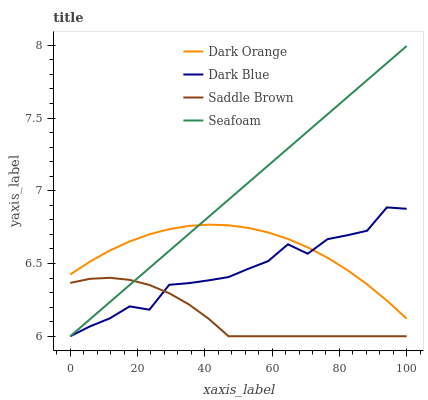Does Saddle Brown have the minimum area under the curve?
Answer yes or no. Yes. Does Seafoam have the maximum area under the curve?
Answer yes or no. Yes. Does Seafoam have the minimum area under the curve?
Answer yes or no. No. Does Saddle Brown have the maximum area under the curve?
Answer yes or no. No. Is Seafoam the smoothest?
Answer yes or no. Yes. Is Dark Blue the roughest?
Answer yes or no. Yes. Is Saddle Brown the smoothest?
Answer yes or no. No. Is Saddle Brown the roughest?
Answer yes or no. No. Does Seafoam have the lowest value?
Answer yes or no. Yes. Does Seafoam have the highest value?
Answer yes or no. Yes. Does Saddle Brown have the highest value?
Answer yes or no. No. Is Saddle Brown less than Dark Orange?
Answer yes or no. Yes. Is Dark Orange greater than Saddle Brown?
Answer yes or no. Yes. Does Seafoam intersect Saddle Brown?
Answer yes or no. Yes. Is Seafoam less than Saddle Brown?
Answer yes or no. No. Is Seafoam greater than Saddle Brown?
Answer yes or no. No. Does Saddle Brown intersect Dark Orange?
Answer yes or no. No. 